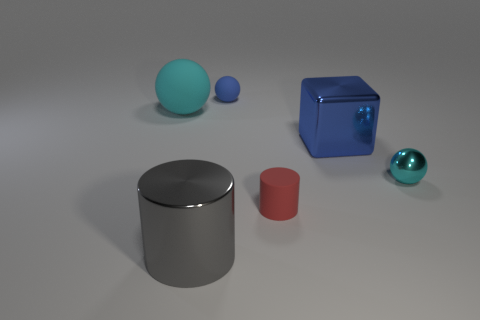Add 2 big cubes. How many objects exist? 8 Add 5 big cylinders. How many big cylinders exist? 6 Subtract 0 cyan blocks. How many objects are left? 6 Subtract all cubes. How many objects are left? 5 Subtract all small cyan shiny balls. Subtract all large spheres. How many objects are left? 4 Add 4 big matte spheres. How many big matte spheres are left? 5 